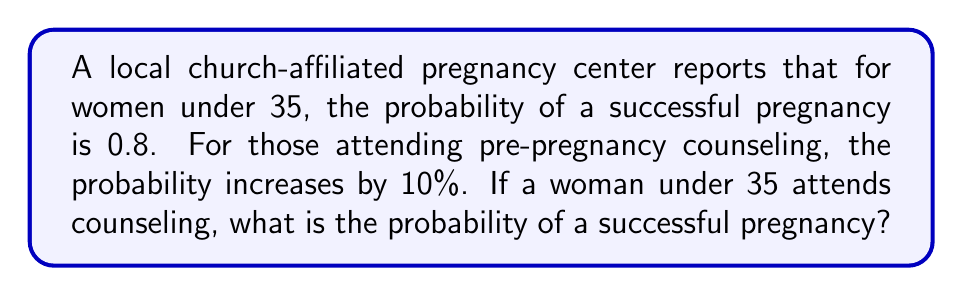Could you help me with this problem? Let's approach this step-by-step:

1) First, we need to identify the given probabilities:
   - For women under 35, the probability of a successful pregnancy is 0.8
   - Attending counseling increases this probability by 10%

2) To calculate a 10% increase, we multiply the original probability by 1.1:

   $$ P(\text{success with counseling}) = 0.8 \times 1.1 $$

3) Let's perform this calculation:

   $$ P(\text{success with counseling}) = 0.8 \times 1.1 = 0.88 $$

4) Therefore, the probability of a successful pregnancy for a woman under 35 who attends counseling is 0.88 or 88%.
Answer: 0.88 